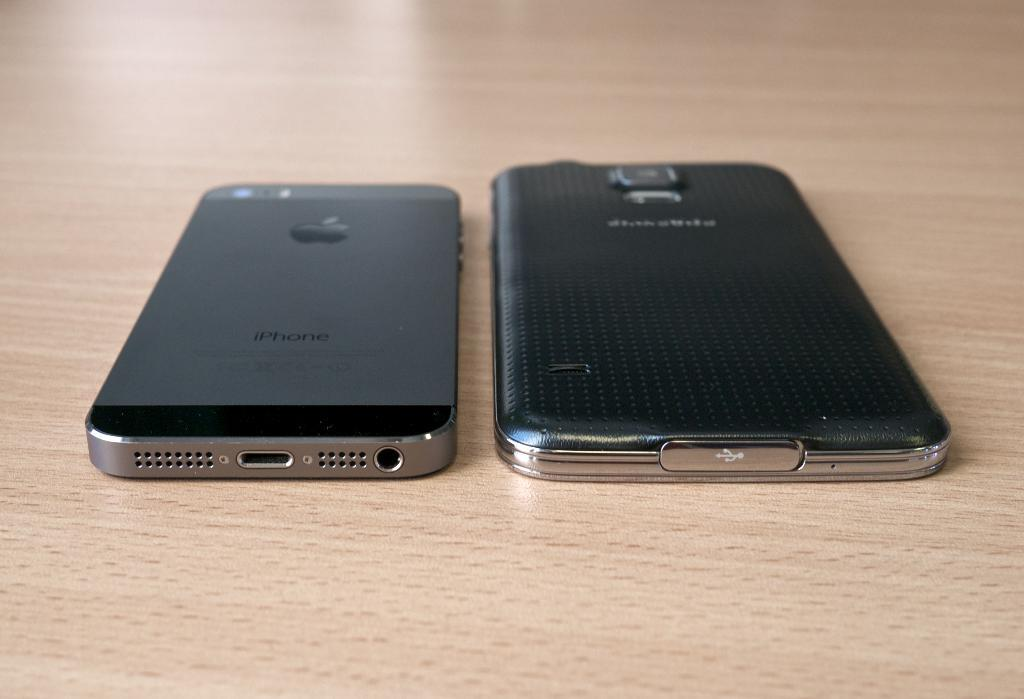<image>
Create a compact narrative representing the image presented. On a table there is an IPhone next to another different type of phone. 